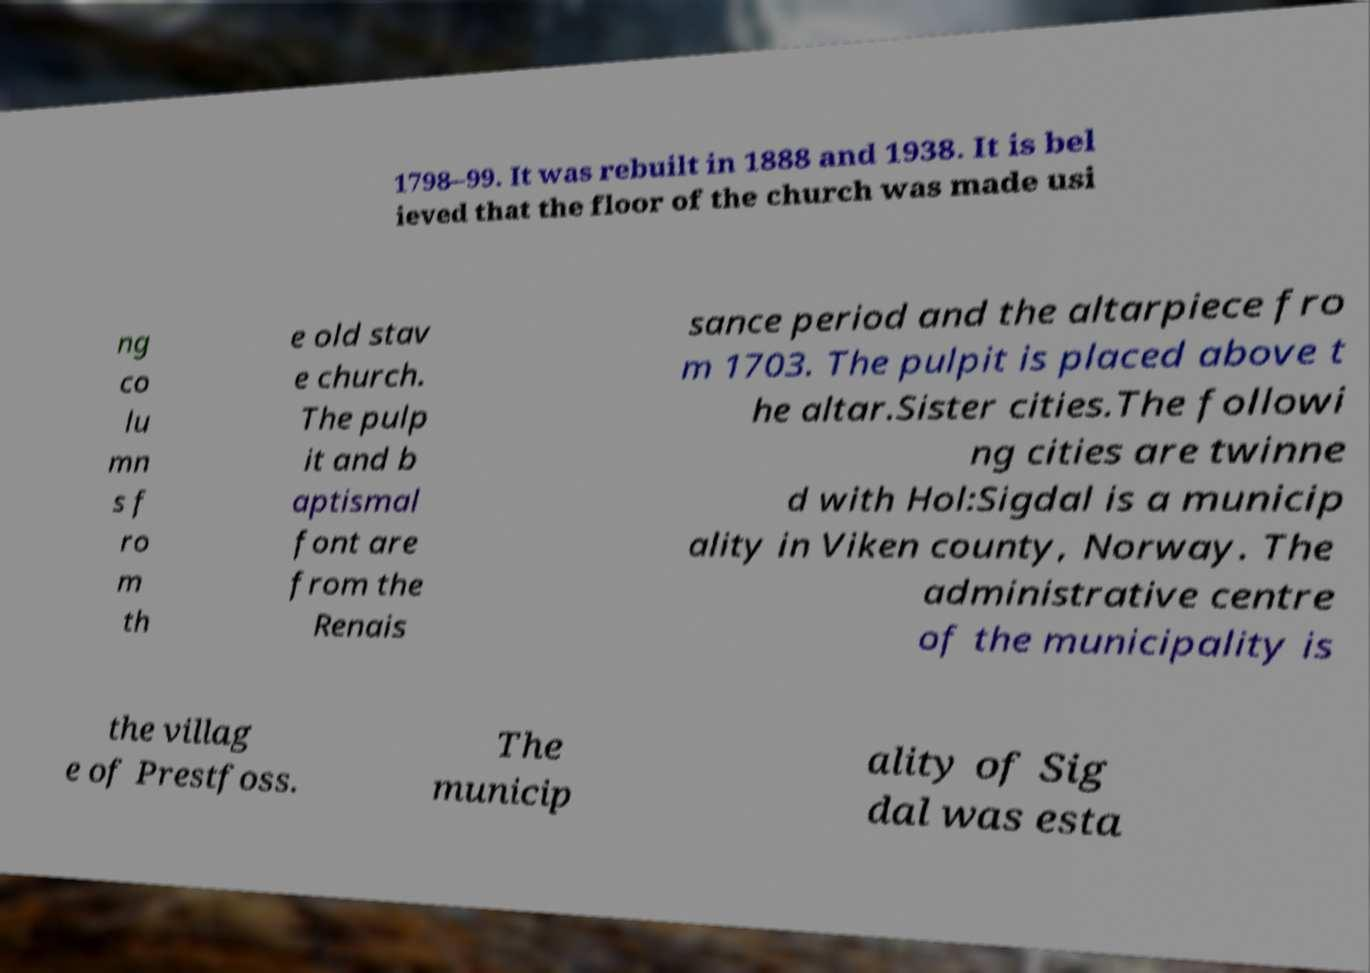For documentation purposes, I need the text within this image transcribed. Could you provide that? 1798–99. It was rebuilt in 1888 and 1938. It is bel ieved that the floor of the church was made usi ng co lu mn s f ro m th e old stav e church. The pulp it and b aptismal font are from the Renais sance period and the altarpiece fro m 1703. The pulpit is placed above t he altar.Sister cities.The followi ng cities are twinne d with Hol:Sigdal is a municip ality in Viken county, Norway. The administrative centre of the municipality is the villag e of Prestfoss. The municip ality of Sig dal was esta 